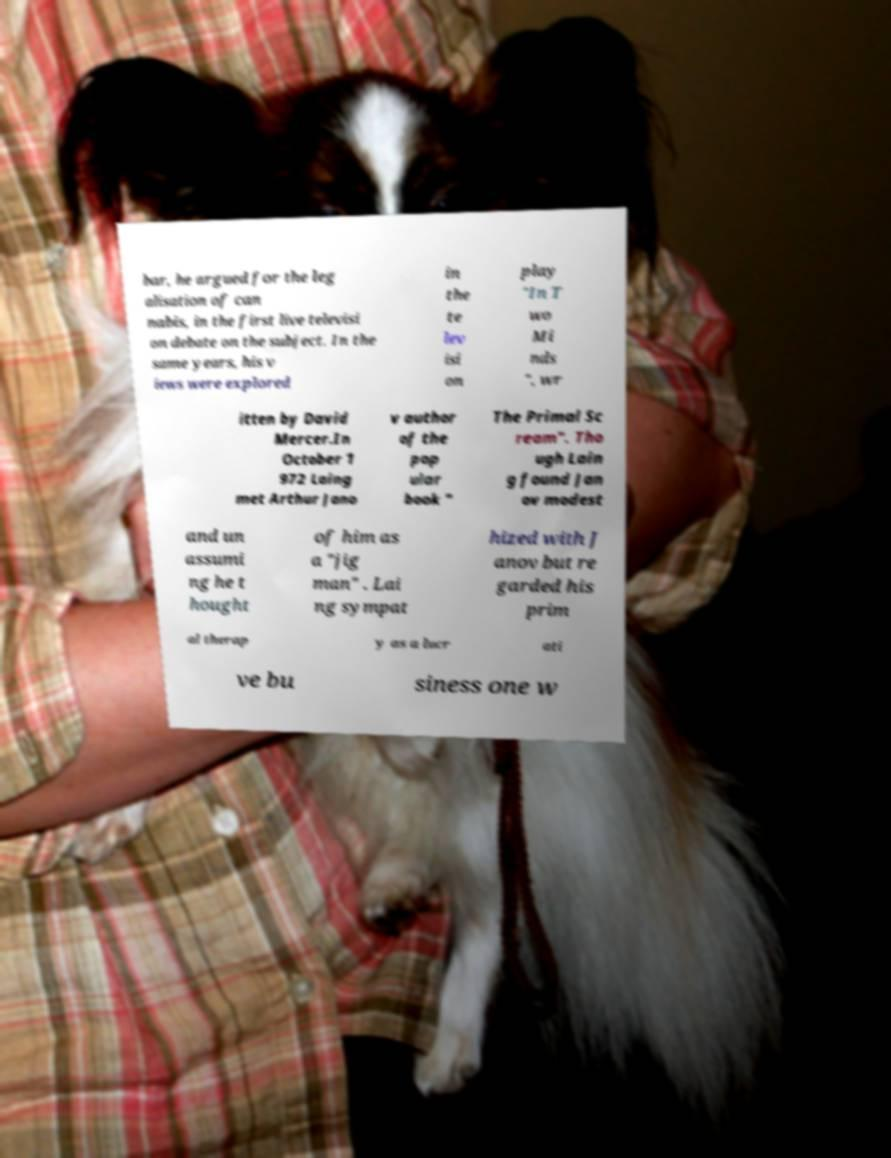I need the written content from this picture converted into text. Can you do that? bar, he argued for the leg alisation of can nabis, in the first live televisi on debate on the subject. In the same years, his v iews were explored in the te lev isi on play "In T wo Mi nds ", wr itten by David Mercer.In October 1 972 Laing met Arthur Jano v author of the pop ular book " The Primal Sc ream". Tho ugh Lain g found Jan ov modest and un assumi ng he t hought of him as a "jig man" . Lai ng sympat hized with J anov but re garded his prim al therap y as a lucr ati ve bu siness one w 